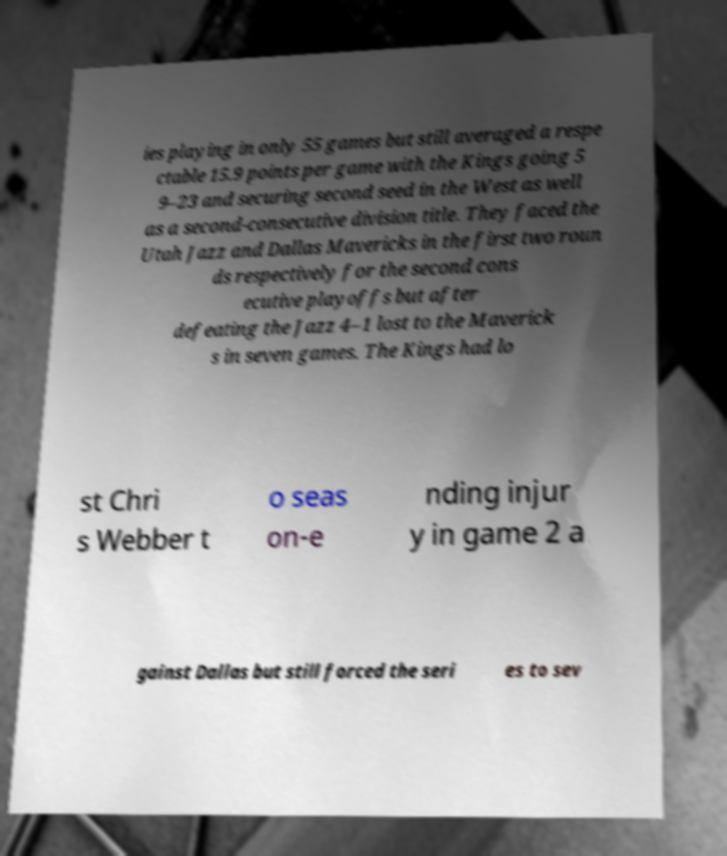Can you accurately transcribe the text from the provided image for me? ies playing in only 55 games but still averaged a respe ctable 15.9 points per game with the Kings going 5 9–23 and securing second seed in the West as well as a second-consecutive division title. They faced the Utah Jazz and Dallas Mavericks in the first two roun ds respectively for the second cons ecutive playoffs but after defeating the Jazz 4–1 lost to the Maverick s in seven games. The Kings had lo st Chri s Webber t o seas on-e nding injur y in game 2 a gainst Dallas but still forced the seri es to sev 